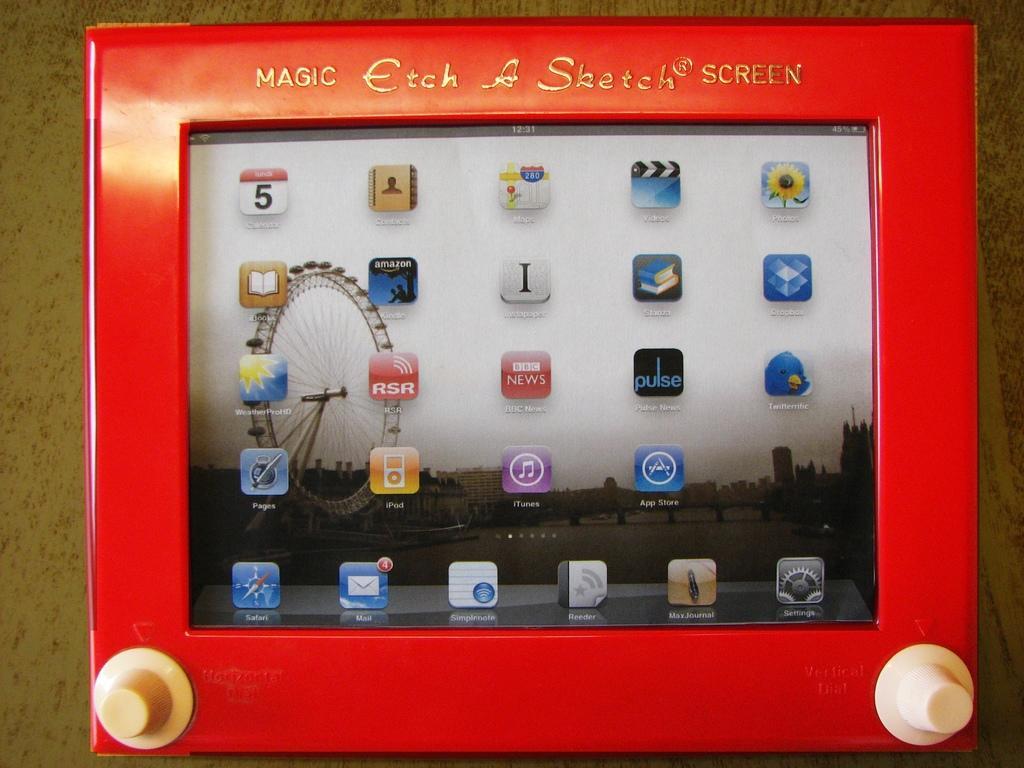How would you summarize this image in a sentence or two? In this picture we can see a frame on the table and in this frame we can see a screen with app icons and a joint wheel. 